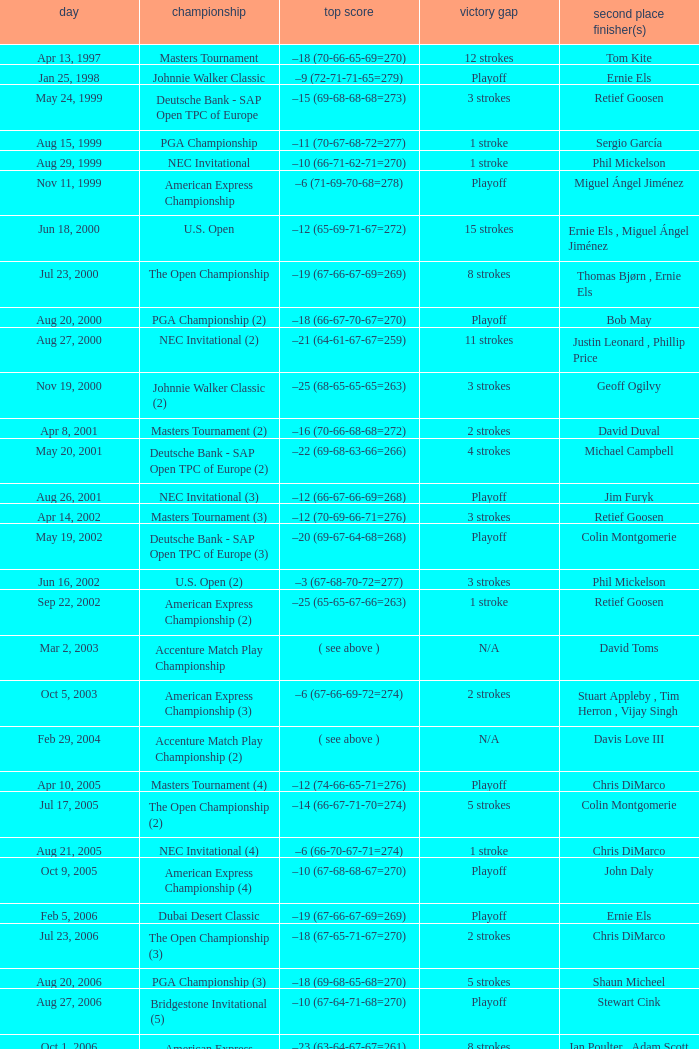Which Tournament has a Margin of victory of 7 strokes Bridgestone Invitational (8). 